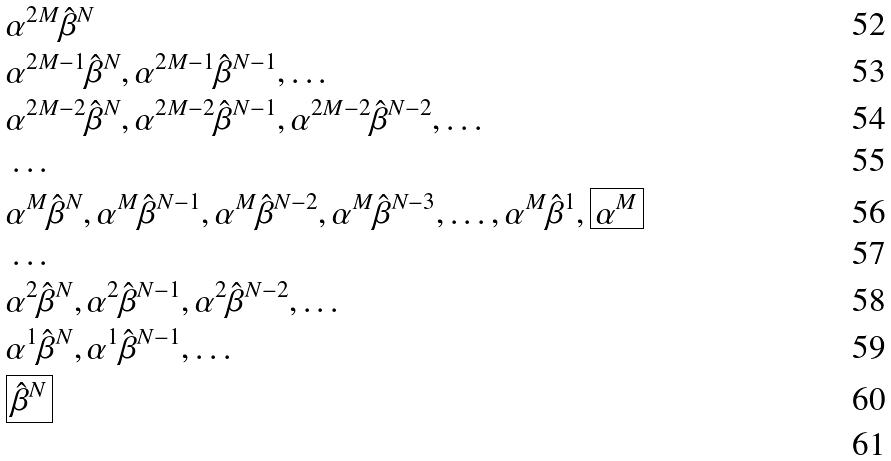Convert formula to latex. <formula><loc_0><loc_0><loc_500><loc_500>& \alpha ^ { 2 M } \hat { \beta } ^ { N } \\ & \alpha ^ { 2 M - 1 } \hat { \beta } ^ { N } , \alpha ^ { 2 M - 1 } \hat { \beta } ^ { N - 1 } , \dots \\ & \alpha ^ { 2 M - 2 } \hat { \beta } ^ { N } , \alpha ^ { 2 M - 2 } \hat { \beta } ^ { N - 1 } , \alpha ^ { 2 M - 2 } \hat { \beta } ^ { N - 2 } , \dots \\ & \dots \\ & \alpha ^ { M } \hat { \beta } ^ { N } , \alpha ^ { M } \hat { \beta } ^ { N - 1 } , \alpha ^ { M } \hat { \beta } ^ { N - 2 } , \alpha ^ { M } \hat { \beta } ^ { N - 3 } , \dots , \alpha ^ { M } \hat { \beta } ^ { 1 } , \boxed { \alpha ^ { M } } \\ & \dots \\ & \alpha ^ { 2 } \hat { \beta } ^ { N } , \alpha ^ { 2 } \hat { \beta } ^ { N - 1 } , \alpha ^ { 2 } \hat { \beta } ^ { N - 2 } , \dots \\ & \alpha ^ { 1 } \hat { \beta } ^ { N } , \alpha ^ { 1 } \hat { \beta } ^ { N - 1 } , \dots \\ & \boxed { \hat { \beta } ^ { N } } \\</formula> 